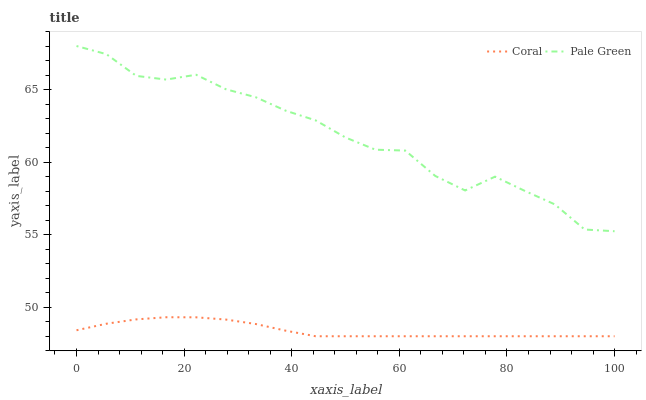Does Coral have the minimum area under the curve?
Answer yes or no. Yes. Does Pale Green have the maximum area under the curve?
Answer yes or no. Yes. Does Pale Green have the minimum area under the curve?
Answer yes or no. No. Is Coral the smoothest?
Answer yes or no. Yes. Is Pale Green the roughest?
Answer yes or no. Yes. Is Pale Green the smoothest?
Answer yes or no. No. Does Coral have the lowest value?
Answer yes or no. Yes. Does Pale Green have the lowest value?
Answer yes or no. No. Does Pale Green have the highest value?
Answer yes or no. Yes. Is Coral less than Pale Green?
Answer yes or no. Yes. Is Pale Green greater than Coral?
Answer yes or no. Yes. Does Coral intersect Pale Green?
Answer yes or no. No. 